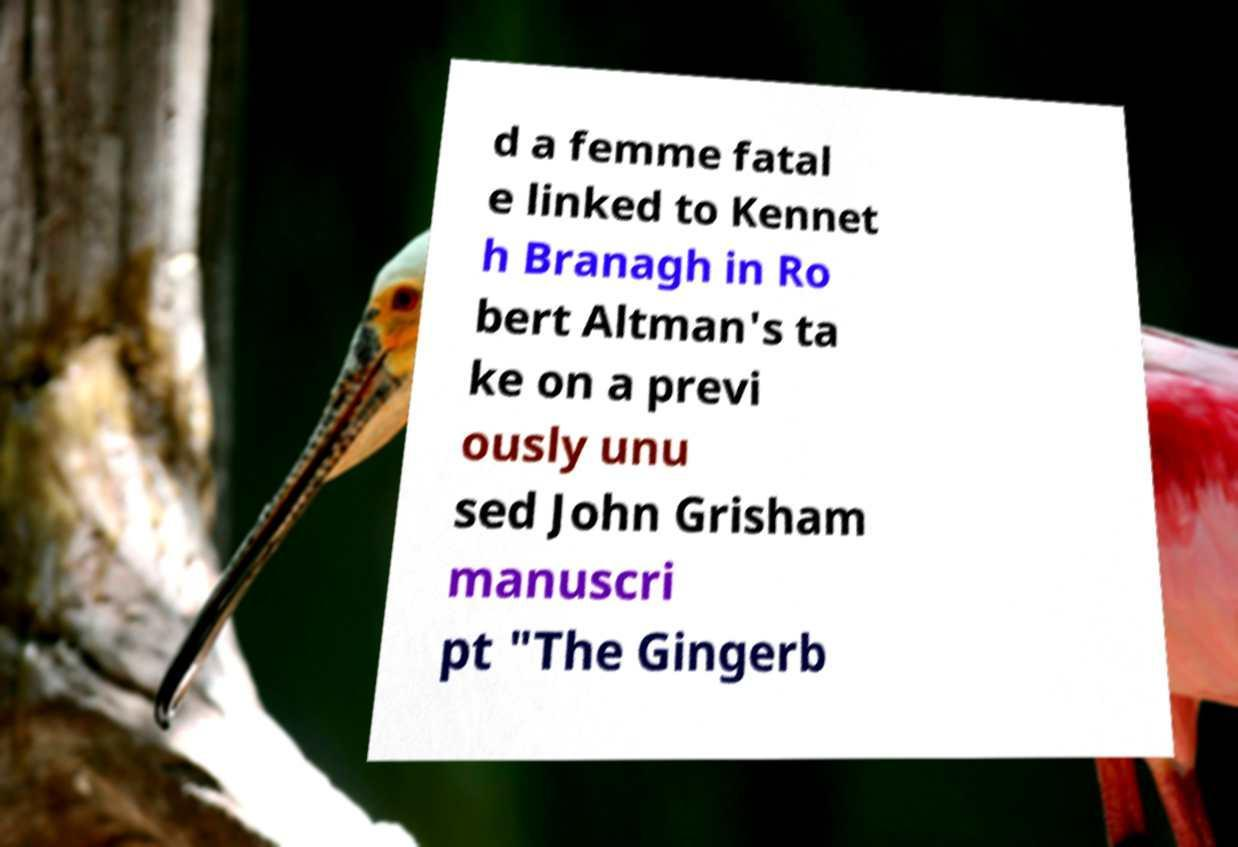Could you extract and type out the text from this image? d a femme fatal e linked to Kennet h Branagh in Ro bert Altman's ta ke on a previ ously unu sed John Grisham manuscri pt "The Gingerb 